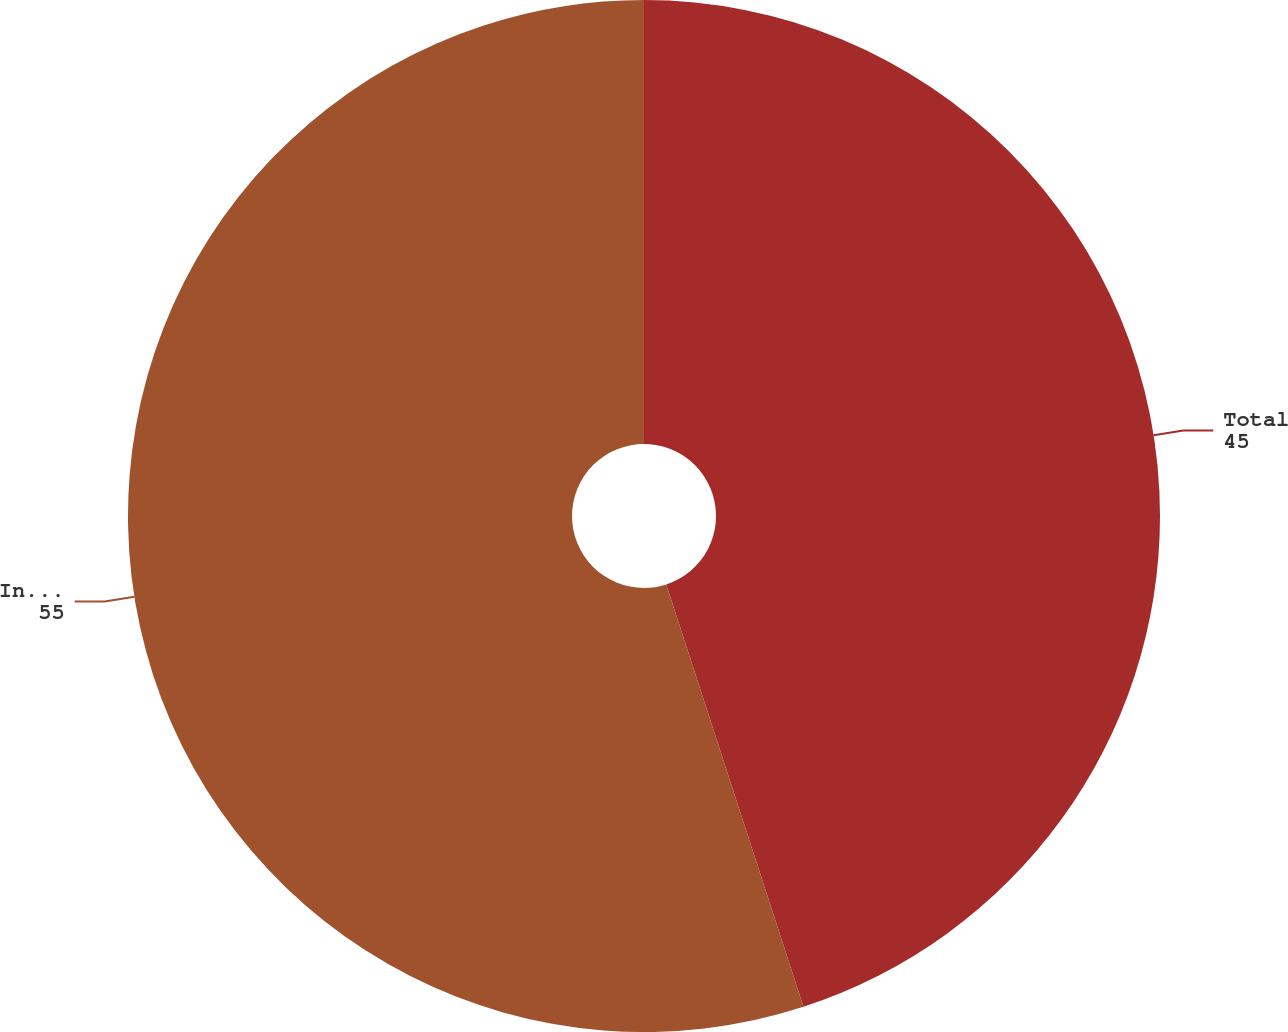Convert chart. <chart><loc_0><loc_0><loc_500><loc_500><pie_chart><fcel>Total<fcel>International<nl><fcel>45.0%<fcel>55.0%<nl></chart> 